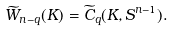Convert formula to latex. <formula><loc_0><loc_0><loc_500><loc_500>\widetilde { W } _ { n - q } ( K ) = \widetilde { C } _ { q } ( K , S ^ { n - 1 } ) .</formula> 